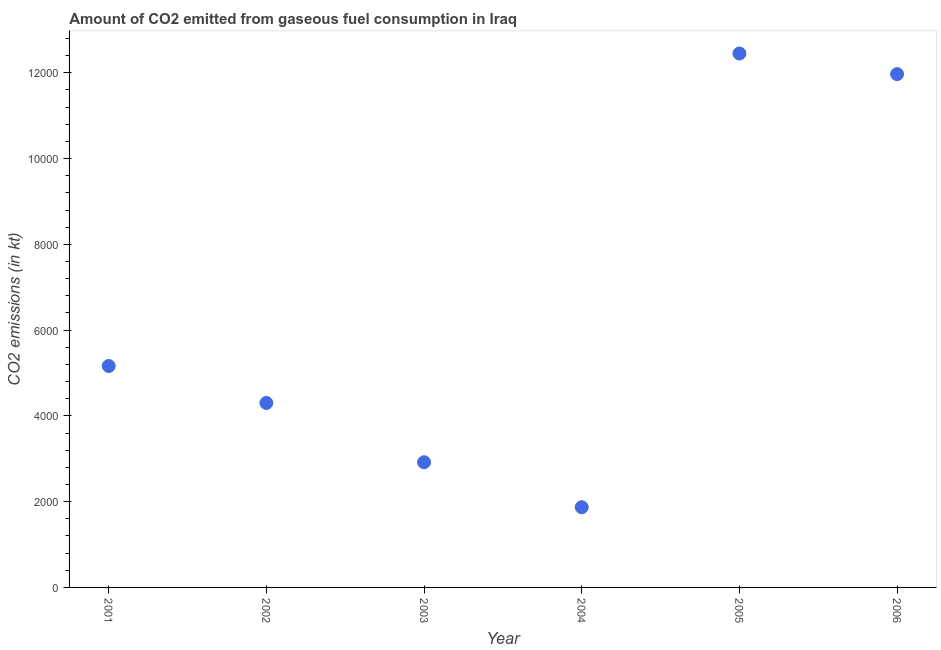What is the co2 emissions from gaseous fuel consumption in 2005?
Provide a succinct answer. 1.24e+04. Across all years, what is the maximum co2 emissions from gaseous fuel consumption?
Ensure brevity in your answer.  1.24e+04. Across all years, what is the minimum co2 emissions from gaseous fuel consumption?
Offer a terse response. 1870.17. What is the sum of the co2 emissions from gaseous fuel consumption?
Your answer should be compact. 3.87e+04. What is the difference between the co2 emissions from gaseous fuel consumption in 2001 and 2003?
Offer a very short reply. 2244.2. What is the average co2 emissions from gaseous fuel consumption per year?
Your answer should be very brief. 6445.36. What is the median co2 emissions from gaseous fuel consumption?
Make the answer very short. 4732.26. Do a majority of the years between 2005 and 2002 (inclusive) have co2 emissions from gaseous fuel consumption greater than 2400 kt?
Provide a short and direct response. Yes. What is the ratio of the co2 emissions from gaseous fuel consumption in 2001 to that in 2004?
Your answer should be compact. 2.76. What is the difference between the highest and the second highest co2 emissions from gaseous fuel consumption?
Ensure brevity in your answer.  480.38. Is the sum of the co2 emissions from gaseous fuel consumption in 2001 and 2006 greater than the maximum co2 emissions from gaseous fuel consumption across all years?
Your answer should be very brief. Yes. What is the difference between the highest and the lowest co2 emissions from gaseous fuel consumption?
Keep it short and to the point. 1.06e+04. In how many years, is the co2 emissions from gaseous fuel consumption greater than the average co2 emissions from gaseous fuel consumption taken over all years?
Your answer should be very brief. 2. Does the co2 emissions from gaseous fuel consumption monotonically increase over the years?
Provide a short and direct response. No. How many dotlines are there?
Ensure brevity in your answer.  1. How many years are there in the graph?
Make the answer very short. 6. Are the values on the major ticks of Y-axis written in scientific E-notation?
Offer a terse response. No. Does the graph contain grids?
Offer a very short reply. No. What is the title of the graph?
Make the answer very short. Amount of CO2 emitted from gaseous fuel consumption in Iraq. What is the label or title of the X-axis?
Your answer should be compact. Year. What is the label or title of the Y-axis?
Offer a terse response. CO2 emissions (in kt). What is the CO2 emissions (in kt) in 2001?
Offer a very short reply. 5163.14. What is the CO2 emissions (in kt) in 2002?
Your answer should be compact. 4301.39. What is the CO2 emissions (in kt) in 2003?
Provide a short and direct response. 2918.93. What is the CO2 emissions (in kt) in 2004?
Make the answer very short. 1870.17. What is the CO2 emissions (in kt) in 2005?
Keep it short and to the point. 1.24e+04. What is the CO2 emissions (in kt) in 2006?
Ensure brevity in your answer.  1.20e+04. What is the difference between the CO2 emissions (in kt) in 2001 and 2002?
Give a very brief answer. 861.75. What is the difference between the CO2 emissions (in kt) in 2001 and 2003?
Provide a short and direct response. 2244.2. What is the difference between the CO2 emissions (in kt) in 2001 and 2004?
Keep it short and to the point. 3292.97. What is the difference between the CO2 emissions (in kt) in 2001 and 2005?
Offer a very short reply. -7286.33. What is the difference between the CO2 emissions (in kt) in 2001 and 2006?
Offer a very short reply. -6805.95. What is the difference between the CO2 emissions (in kt) in 2002 and 2003?
Offer a terse response. 1382.46. What is the difference between the CO2 emissions (in kt) in 2002 and 2004?
Offer a terse response. 2431.22. What is the difference between the CO2 emissions (in kt) in 2002 and 2005?
Keep it short and to the point. -8148.07. What is the difference between the CO2 emissions (in kt) in 2002 and 2006?
Ensure brevity in your answer.  -7667.7. What is the difference between the CO2 emissions (in kt) in 2003 and 2004?
Make the answer very short. 1048.76. What is the difference between the CO2 emissions (in kt) in 2003 and 2005?
Give a very brief answer. -9530.53. What is the difference between the CO2 emissions (in kt) in 2003 and 2006?
Make the answer very short. -9050.16. What is the difference between the CO2 emissions (in kt) in 2004 and 2005?
Offer a very short reply. -1.06e+04. What is the difference between the CO2 emissions (in kt) in 2004 and 2006?
Your response must be concise. -1.01e+04. What is the difference between the CO2 emissions (in kt) in 2005 and 2006?
Your answer should be very brief. 480.38. What is the ratio of the CO2 emissions (in kt) in 2001 to that in 2002?
Ensure brevity in your answer.  1.2. What is the ratio of the CO2 emissions (in kt) in 2001 to that in 2003?
Ensure brevity in your answer.  1.77. What is the ratio of the CO2 emissions (in kt) in 2001 to that in 2004?
Ensure brevity in your answer.  2.76. What is the ratio of the CO2 emissions (in kt) in 2001 to that in 2005?
Your answer should be compact. 0.41. What is the ratio of the CO2 emissions (in kt) in 2001 to that in 2006?
Give a very brief answer. 0.43. What is the ratio of the CO2 emissions (in kt) in 2002 to that in 2003?
Make the answer very short. 1.47. What is the ratio of the CO2 emissions (in kt) in 2002 to that in 2004?
Your answer should be very brief. 2.3. What is the ratio of the CO2 emissions (in kt) in 2002 to that in 2005?
Offer a terse response. 0.35. What is the ratio of the CO2 emissions (in kt) in 2002 to that in 2006?
Keep it short and to the point. 0.36. What is the ratio of the CO2 emissions (in kt) in 2003 to that in 2004?
Ensure brevity in your answer.  1.56. What is the ratio of the CO2 emissions (in kt) in 2003 to that in 2005?
Make the answer very short. 0.23. What is the ratio of the CO2 emissions (in kt) in 2003 to that in 2006?
Keep it short and to the point. 0.24. What is the ratio of the CO2 emissions (in kt) in 2004 to that in 2006?
Offer a very short reply. 0.16. 